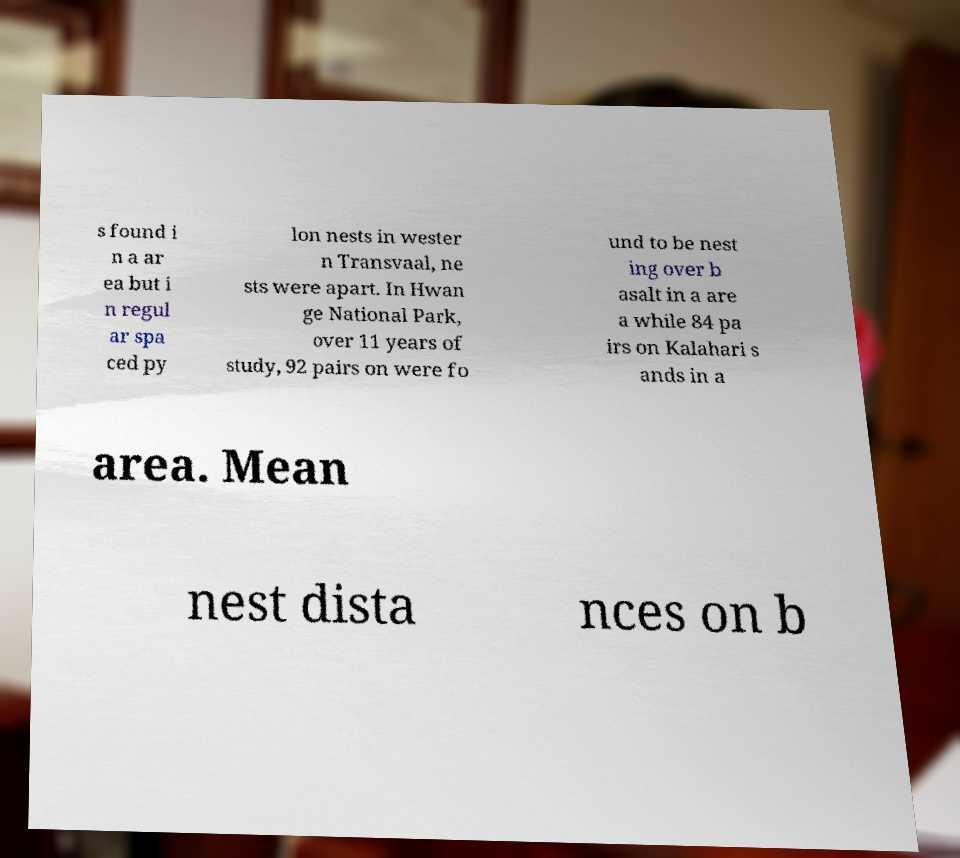Can you read and provide the text displayed in the image?This photo seems to have some interesting text. Can you extract and type it out for me? s found i n a ar ea but i n regul ar spa ced py lon nests in wester n Transvaal, ne sts were apart. In Hwan ge National Park, over 11 years of study, 92 pairs on were fo und to be nest ing over b asalt in a are a while 84 pa irs on Kalahari s ands in a area. Mean nest dista nces on b 